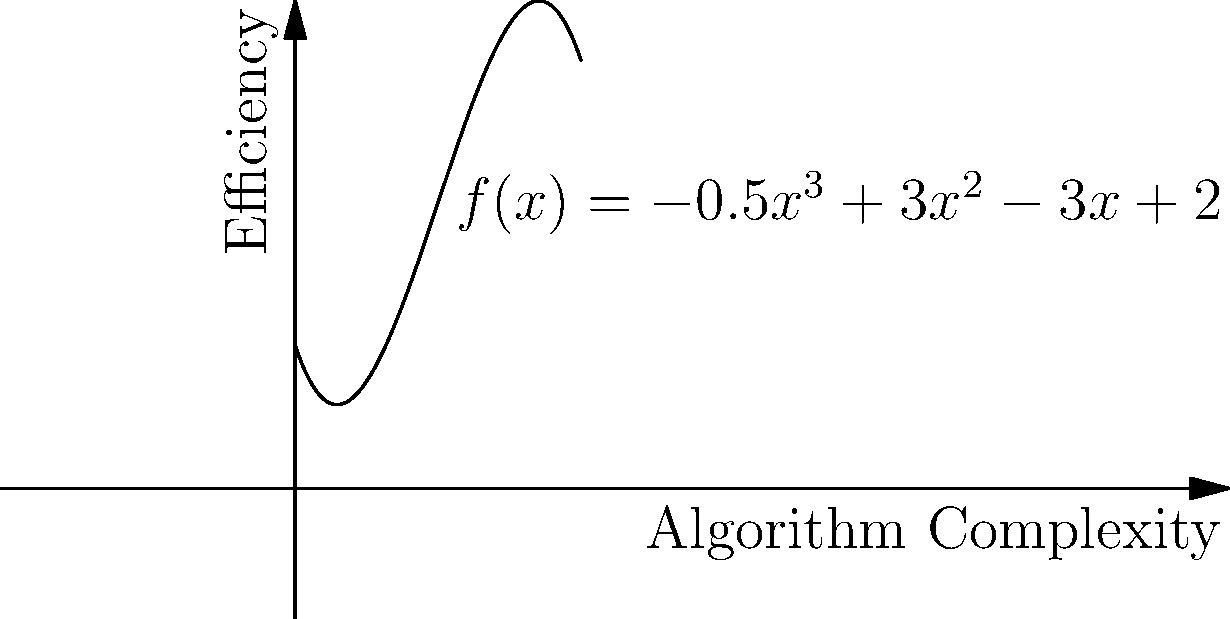The graph represents the efficiency of different hacking algorithms based on their complexity. The function is given by $f(x) = -0.5x^3 + 3x^2 - 3x + 2$, where $x$ represents the algorithm complexity and $f(x)$ represents the efficiency. Find the critical points of this function and determine which point represents the optimal balance between complexity and efficiency for a hacking algorithm. To find the critical points, we need to follow these steps:

1) Find the derivative of the function:
   $f'(x) = -1.5x^2 + 6x - 3$

2) Set the derivative equal to zero and solve for x:
   $-1.5x^2 + 6x - 3 = 0$
   
3) This is a quadratic equation. We can solve it using the quadratic formula:
   $x = \frac{-b \pm \sqrt{b^2 - 4ac}}{2a}$
   
   Where $a = -1.5$, $b = 6$, and $c = -3$

4) Plugging in these values:
   $x = \frac{-6 \pm \sqrt{36 - 4(-1.5)(-3)}}{2(-1.5)}$
   $= \frac{-6 \pm \sqrt{36 - 18}}{-3}$
   $= \frac{-6 \pm \sqrt{18}}{-3}$
   $= \frac{-6 \pm 3\sqrt{2}}{-3}$

5) Simplifying:
   $x_1 = \frac{-6 + 3\sqrt{2}}{-3} = 2 - \sqrt{2}$
   $x_2 = \frac{-6 - 3\sqrt{2}}{-3} = 2 + \sqrt{2}$

6) To determine which point represents the optimal balance, we need to evaluate $f(x)$ at both critical points:

   $f(2 - \sqrt{2}) \approx 4.45$
   $f(2 + \sqrt{2}) \approx 2.45$

   The higher value represents better efficiency, so $x = 2 - \sqrt{2}$ is the optimal point.
Answer: Critical points: $x = 2 - \sqrt{2}$ and $x = 2 + \sqrt{2}$. Optimal point: $x = 2 - \sqrt{2}$. 